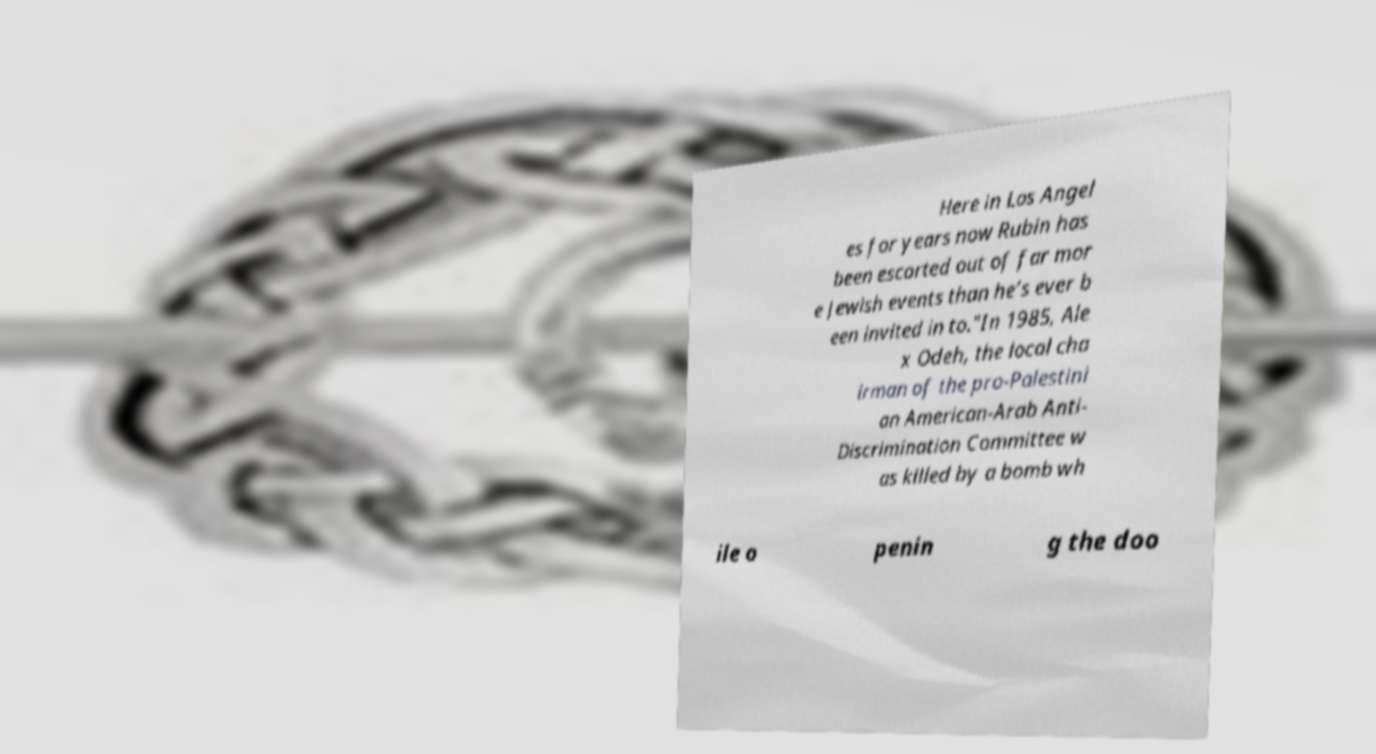Could you assist in decoding the text presented in this image and type it out clearly? Here in Los Angel es for years now Rubin has been escorted out of far mor e Jewish events than he’s ever b een invited in to."In 1985, Ale x Odeh, the local cha irman of the pro-Palestini an American-Arab Anti- Discrimination Committee w as killed by a bomb wh ile o penin g the doo 